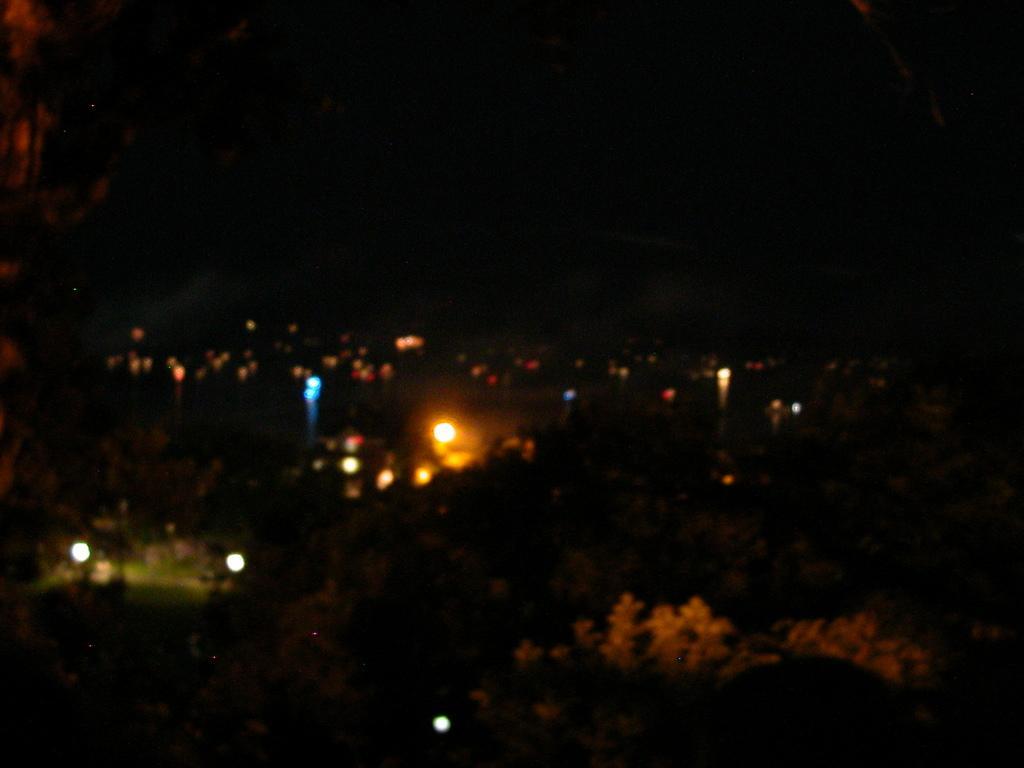How would you summarize this image in a sentence or two? In this picture we can see few lights and trees. 